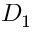Convert formula to latex. <formula><loc_0><loc_0><loc_500><loc_500>D _ { 1 }</formula> 